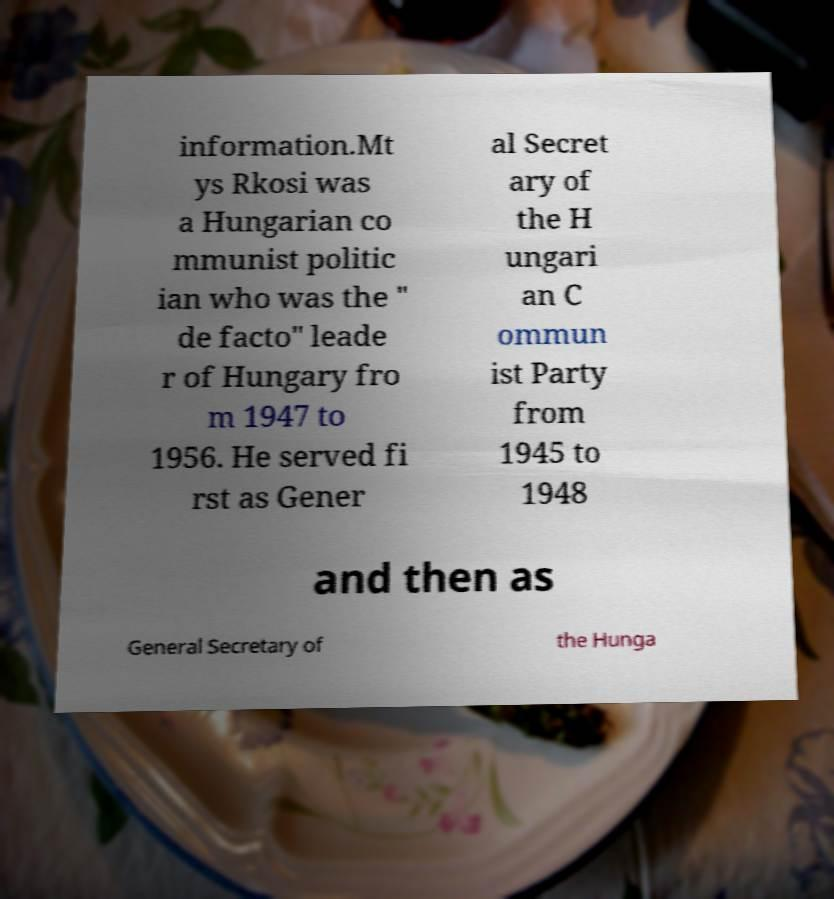Please read and relay the text visible in this image. What does it say? information.Mt ys Rkosi was a Hungarian co mmunist politic ian who was the " de facto" leade r of Hungary fro m 1947 to 1956. He served fi rst as Gener al Secret ary of the H ungari an C ommun ist Party from 1945 to 1948 and then as General Secretary of the Hunga 